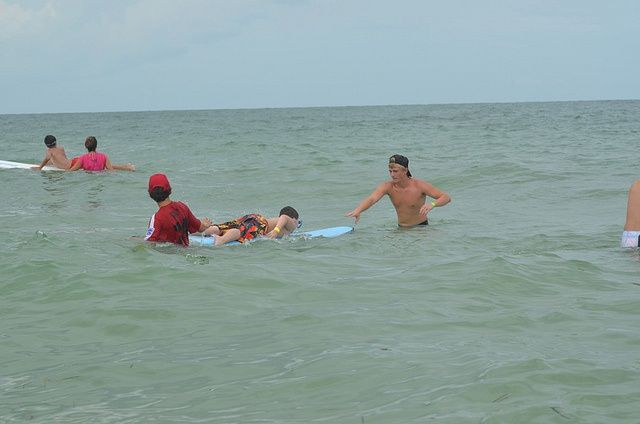Describe the objects in this image and their specific colors. I can see people in lightgray, gray, darkgray, and salmon tones, people in lightgray, maroon, brown, and black tones, people in lightgray, gray, darkgray, and tan tones, people in lightgray, tan, darkgray, and gray tones, and people in lightgray, gray, darkgray, and black tones in this image. 